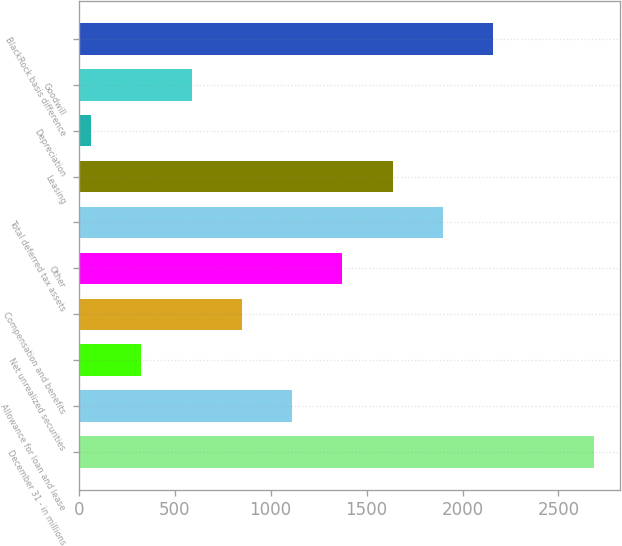Convert chart. <chart><loc_0><loc_0><loc_500><loc_500><bar_chart><fcel>December 31 - in millions<fcel>Allowance for loan and lease<fcel>Net unrealized securities<fcel>Compensation and benefits<fcel>Other<fcel>Total deferred tax assets<fcel>Leasing<fcel>Depreciation<fcel>Goodwill<fcel>BlackRock basis difference<nl><fcel>2684<fcel>1112.6<fcel>326.9<fcel>850.7<fcel>1374.5<fcel>1898.3<fcel>1636.4<fcel>65<fcel>588.8<fcel>2160.2<nl></chart> 